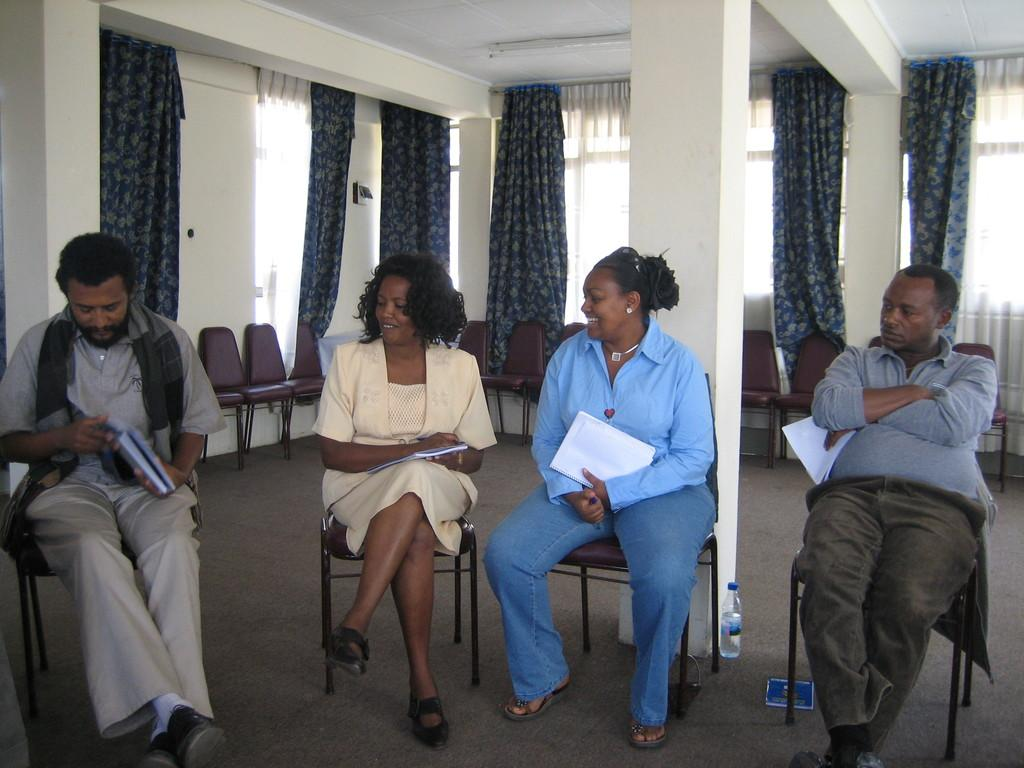How many people are sitting in the image? There are four persons sitting on chairs in the image. What are the persons holding in their hands? The persons are holding books. Are there any empty chairs in the image? Yes, there are additional chairs behind the seated persons. What type of window treatment can be seen in the image? There are curtains visible in the image. What is located at the bottom of the image? There is a mat at the bottom of the image. What type of weather condition is affecting the knowledge of the persons in the image? There is no mention of any weather condition affecting the knowledge of the persons in the image. 